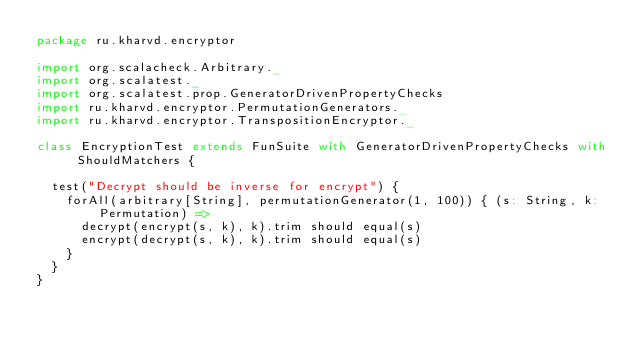<code> <loc_0><loc_0><loc_500><loc_500><_Scala_>package ru.kharvd.encryptor

import org.scalacheck.Arbitrary._
import org.scalatest._
import org.scalatest.prop.GeneratorDrivenPropertyChecks
import ru.kharvd.encryptor.PermutationGenerators._
import ru.kharvd.encryptor.TranspositionEncryptor._

class EncryptionTest extends FunSuite with GeneratorDrivenPropertyChecks with ShouldMatchers {

  test("Decrypt should be inverse for encrypt") {
    forAll(arbitrary[String], permutationGenerator(1, 100)) { (s: String, k: Permutation) =>
      decrypt(encrypt(s, k), k).trim should equal(s)
      encrypt(decrypt(s, k), k).trim should equal(s)
    }
  }
}
</code> 